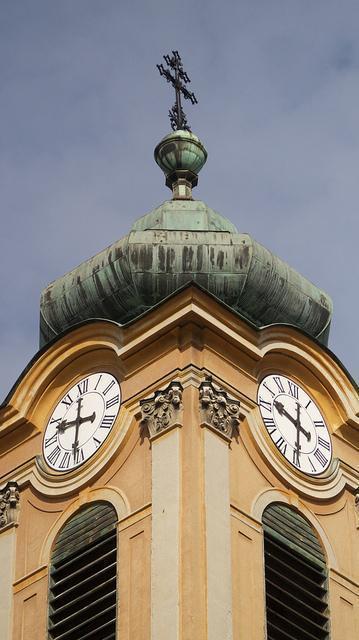How many clocks on the building?
Give a very brief answer. 2. How many clocks can you see?
Give a very brief answer. 2. 